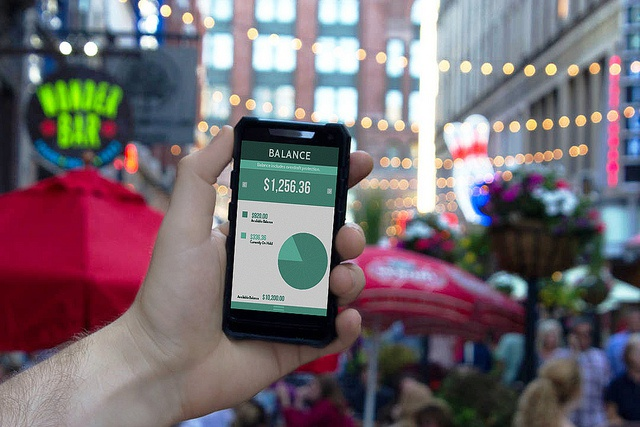Describe the objects in this image and their specific colors. I can see people in black, darkgray, and gray tones, cell phone in black, lightgray, and teal tones, umbrella in black, maroon, and brown tones, umbrella in black, maroon, gray, and purple tones, and people in black and gray tones in this image. 